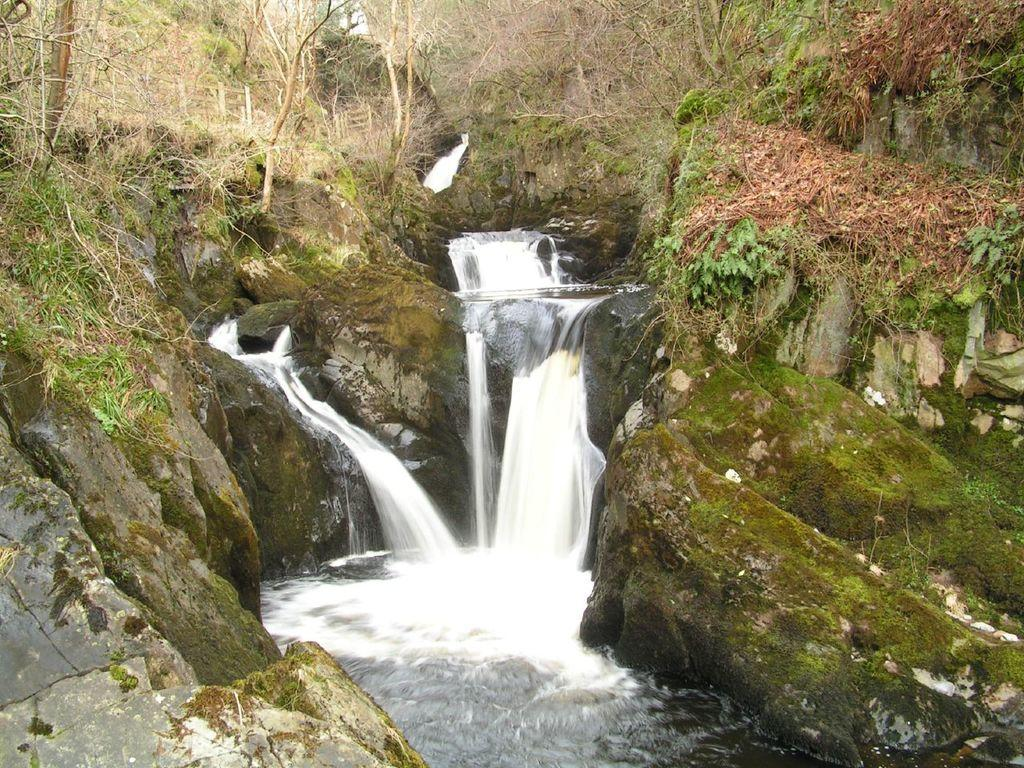What is the main subject of the image? The main subject of the image is a waterfall. Where is the waterfall located in the image? The waterfall is in the center of the image. What can be seen in the background of the image? There are trees visible in the background of the image. What type of insurance is required to visit the waterfall in the image? There is no information about insurance or visiting the waterfall in the image. The image simply shows a waterfall and trees in the background. 